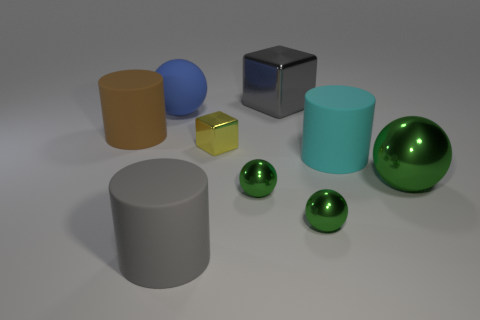What number of blue rubber spheres have the same size as the cyan matte cylinder?
Give a very brief answer. 1. Is the number of balls that are in front of the cyan rubber thing the same as the number of large shiny things?
Your answer should be very brief. No. How many rubber objects are both in front of the big green object and behind the big cyan rubber object?
Give a very brief answer. 0. Do the matte object on the left side of the blue sphere and the gray rubber thing have the same shape?
Offer a terse response. Yes. There is a gray thing that is the same size as the gray metal block; what is its material?
Give a very brief answer. Rubber. Are there an equal number of small things on the right side of the yellow thing and small metallic spheres left of the matte ball?
Make the answer very short. No. There is a small green object that is to the right of the large metallic thing that is behind the yellow metal block; how many tiny yellow things are in front of it?
Keep it short and to the point. 0. Is the color of the large cube the same as the large rubber thing that is in front of the cyan cylinder?
Keep it short and to the point. Yes. There is a brown object that is made of the same material as the gray cylinder; what is its size?
Offer a very short reply. Large. Are there more big green objects behind the matte sphere than large cyan things?
Your answer should be very brief. No. 